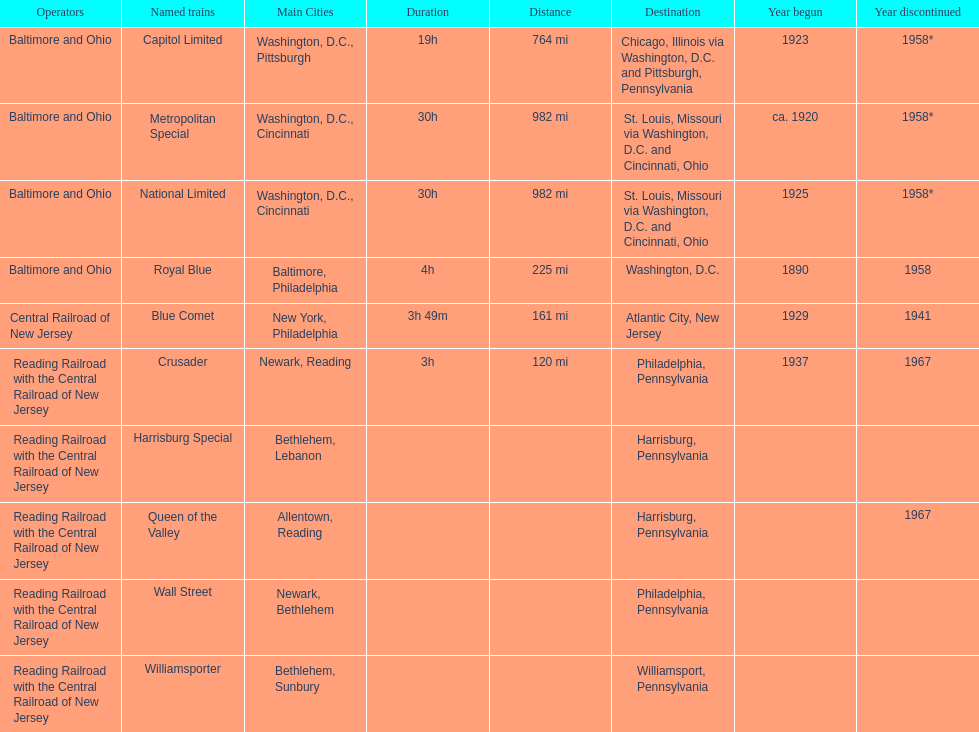How many trains were discontinued in 1958? 4. 